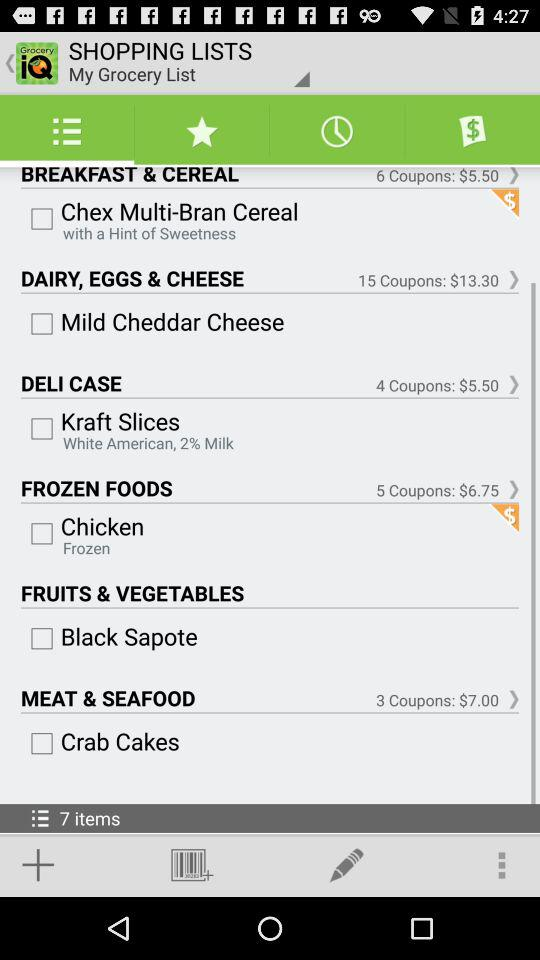What item is available for breakfast & cereal? The available item for breakfast and cereal is Chex Multi-Bran Cereal. 